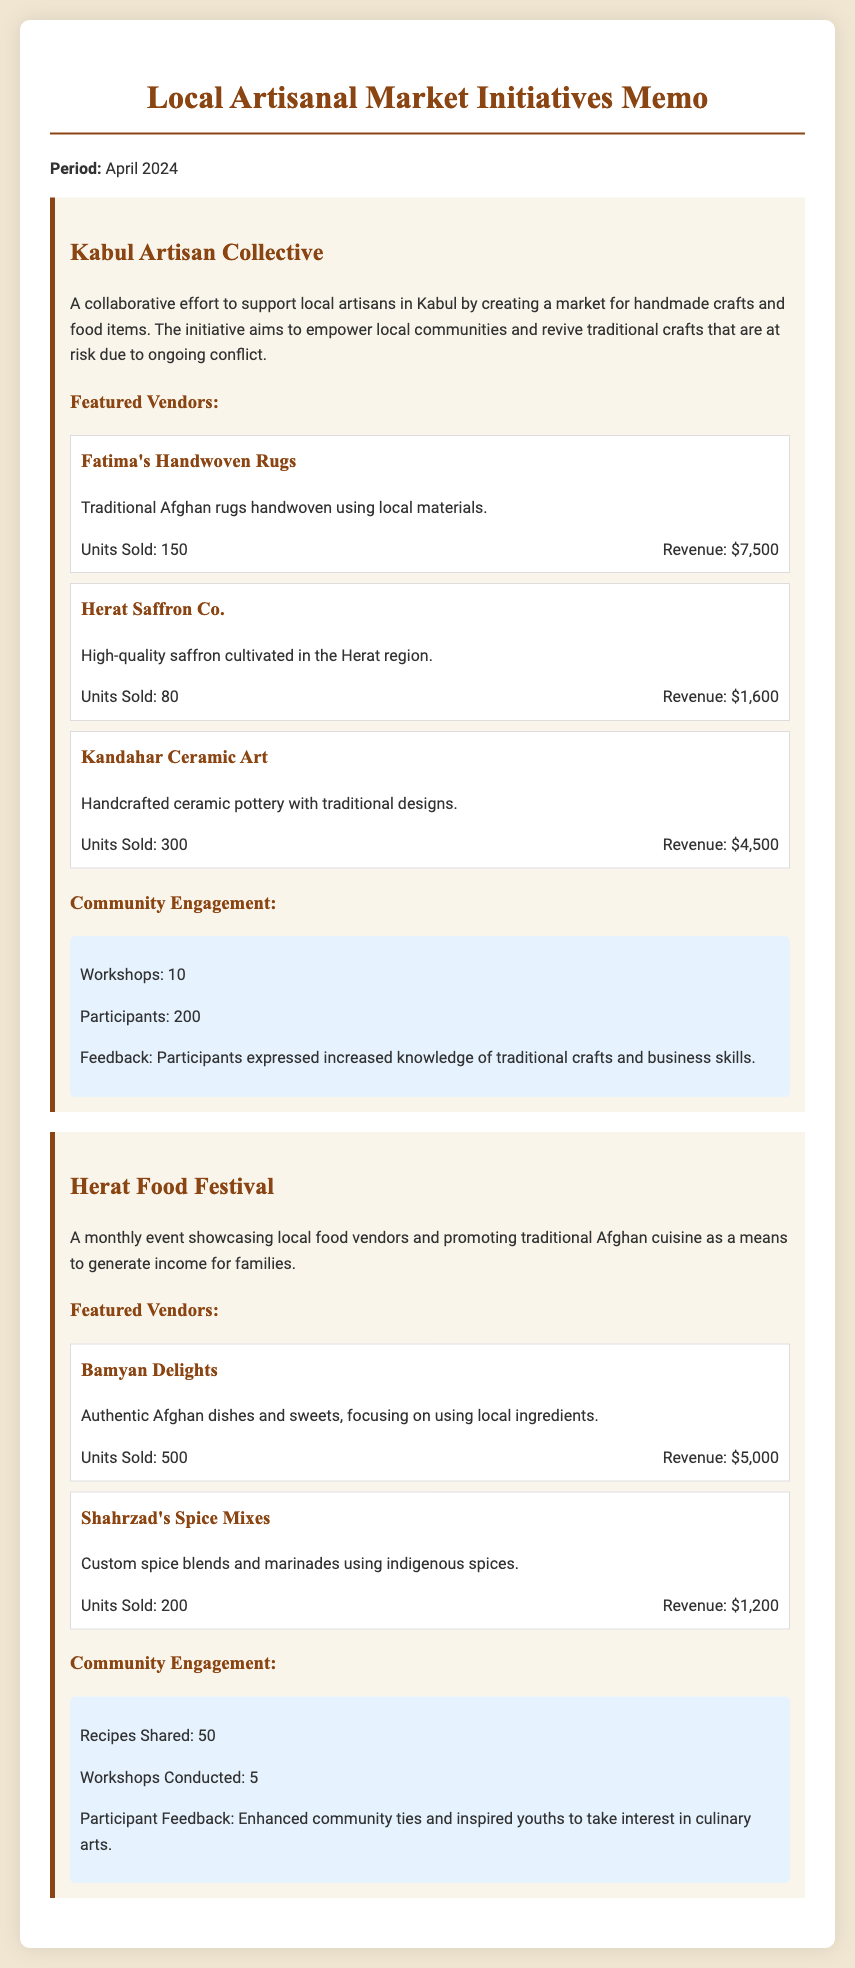What is the total number of workshops conducted in the Kabul Artisan Collective? The total number of workshops is stated directly in the document under the community engagement section for the Kabul Artisan Collective.
Answer: 10 What is the revenue generated by Fatima's Handwoven Rugs? The revenue generated by Fatima's Handwoven Rugs is found in the performance section for that vendor.
Answer: $7,500 How many units of Kandahar Ceramic Art were sold? The number of units sold for Kandahar Ceramic Art is listed in the performance section for that vendor.
Answer: 300 What is the main goal of the Herat Food Festival? The main goal of the Herat Food Festival is mentioned in the introductory paragraph of the initiative section.
Answer: Generate income for families How many participants attended the workshops in the Kabul Artisan Collective? The number of participants is provided in the community engagement section for the Kabul Artisan Collective.
Answer: 200 What is the total revenue from the Herat Food Festival vendors? Total revenue is determined by summing the revenues of all featured vendors in the Herat Food Festival.
Answer: $6,200 What percentage of vendors in the Kabul Artisan Collective focus on food items? The percentage is determined by analyzing the number of food-related vendors compared to the total number of featured vendors.
Answer: 0% How many recipes were shared during the Herat Food Festival? The number of recipes shared is noted in the community engagement section for the event.
Answer: 50 What type of products does Shahrzad's Spice Mixes offer? The type of products offered by Shahrzad's Spice Mixes is described in the vendor's section of the document.
Answer: Custom spice blends and marinades 